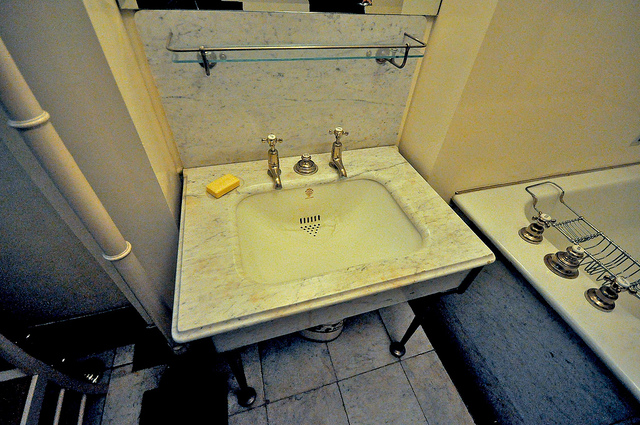Can you describe the light conditions in the bathroom? The light conditions in the bathroom seem to be moderately bright, suggesting a well-lit environment, possibly with artificial lighting such as ceiling lights or wall-mounted fixtures. The surfaces of the sink and countertop are clearly visible, indicative of good lighting. How does the lighting affect the appearance of the marble countertop? The lighting enhances the appearance of the marble countertop, highlighting its natural veining and providing a glossy finish that emphasizes its smooth texture. Good lighting reveals the fine details and contributes to a clean, sophisticated look in the bathroom. Imagine if the bathroom underwent a transformation, what changes would you suggest to enhance its aesthetic and functionality? To transform and enhance the bathroom's aesthetic and functionality, I would suggest the following changes:
1. **Lighting Upgrade**: Install a combination of ambient, task, and accent lighting to create a versatile and inviting atmosphere. Consider dimmable LED fixtures for energy efficiency.
2. **Storage Solutions**: Add additional floating shelves or stylish cabinetry to keep toiletries organized and the countertop clutter-free.
3. **Mirror with Integrated Lighting**: Upgrade to a modern mirror with built-in lighting to improve visibility and add a touch of elegance.
4. **Faucet and Fixture Upgrade**: Replace the existing metal fixtures with sleek, contemporary designs in finishes like brushed nickel or matte black.
5. **Accent Tiles**: Introduce decorative tiles as a backsplash behind the sink or as an accent wall to add visual interest.
6. **Plants and Greenery**: Incorporate low-maintenance indoor plants to add a natural element and enhance air quality.
7. **Smart Features**: Add smart faucets and shower controls for improved water usage efficiency and convenience. 